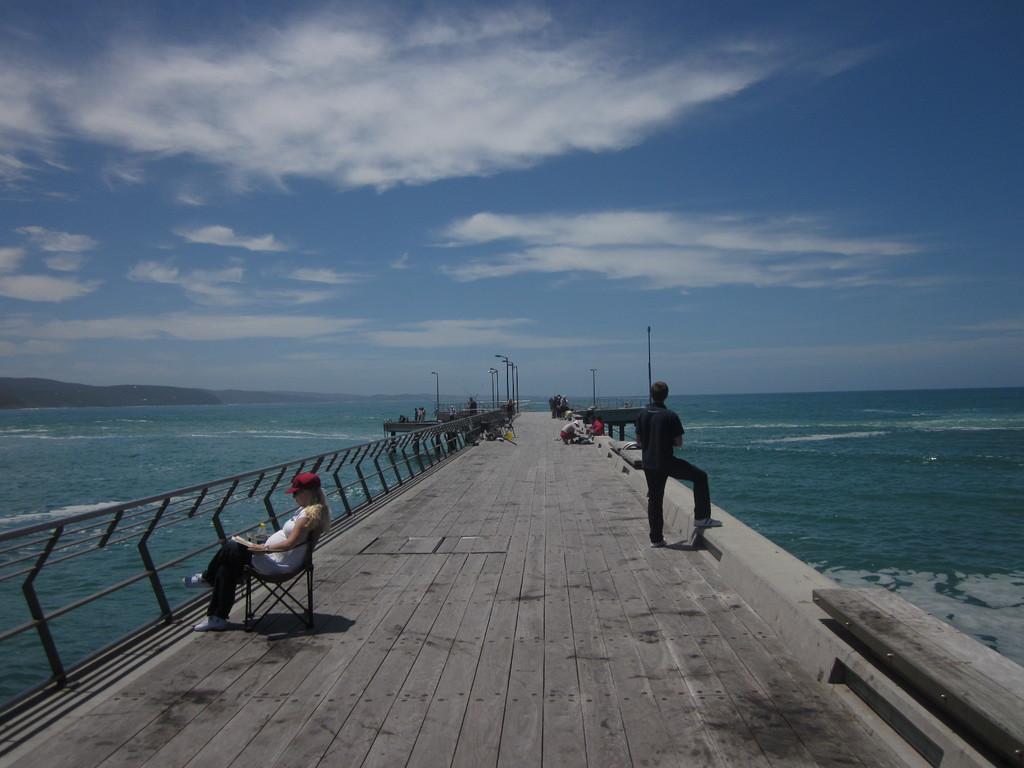Can you describe this image briefly? In this image, we can see persons on the bridge. There is a sea in the middle of the image. In the background of the image, there is a sky. 